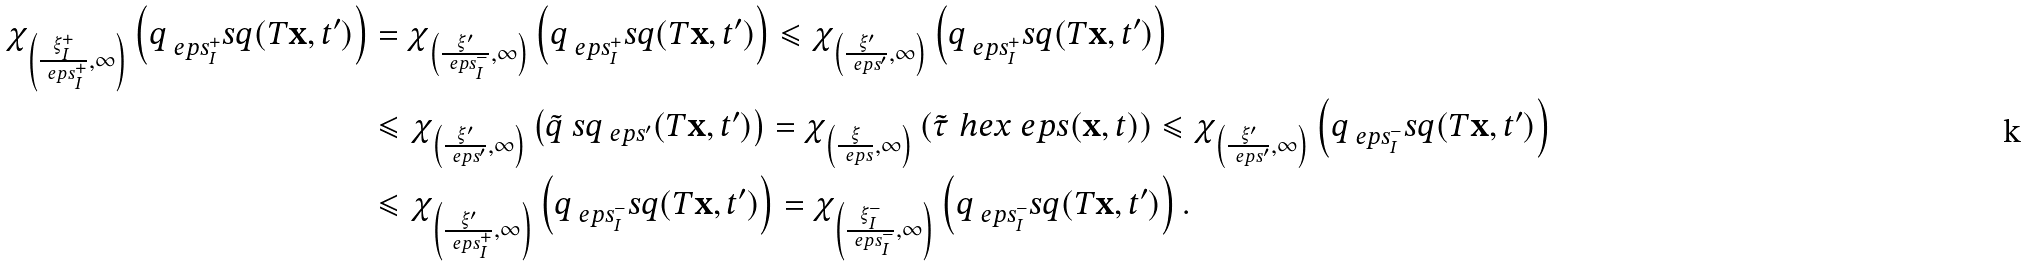Convert formula to latex. <formula><loc_0><loc_0><loc_500><loc_500>\chi _ { \left ( \frac { \xi ^ { + } _ { I } } { \ e p s ^ { + } _ { I } } , \infty \right ) } \left ( q _ { \ e p s ^ { + } _ { I } } ^ { \ } s q ( T { \mathbf x } , t ^ { \prime } ) \right ) & = \chi _ { \left ( \frac { \xi ^ { \prime } } { \ e p s ^ { - } _ { I } } , \infty \right ) } \left ( q _ { \ e p s ^ { + } _ { I } } ^ { \ } s q ( T { \mathbf x } , t ^ { \prime } ) \right ) \leqslant \chi _ { \left ( \frac { \xi ^ { \prime } } { \ e p s ^ { \prime } } , \infty \right ) } \left ( q _ { \ e p s ^ { + } _ { I } } ^ { \ } s q ( T { \mathbf x } , t ^ { \prime } ) \right ) \\ & \leqslant \chi _ { \left ( \frac { \xi ^ { \prime } } { \ e p s ^ { \prime } } , \infty \right ) } \left ( \tilde { q } ^ { \ } s q _ { \ e p s ^ { \prime } } ( T { \mathbf x } , t ^ { \prime } ) \right ) = \chi _ { \left ( \frac { \xi } { \ e p s } , \infty \right ) } \left ( \tilde { \tau } ^ { \ } h e x _ { \ } e p s ( { \mathbf x } , t ) \right ) \leqslant \chi _ { \left ( \frac { \xi ^ { \prime } } { \ e p s ^ { \prime } } , \infty \right ) } \left ( q _ { \ e p s ^ { - } _ { I } } ^ { \ } s q ( T { \mathbf x } , t ^ { \prime } ) \right ) \\ & \leqslant \chi _ { \left ( \frac { \xi ^ { \prime } } { \ e p s ^ { + } _ { I } } , \infty \right ) } \left ( q _ { \ e p s ^ { - } _ { I } } ^ { \ } s q ( T { \mathbf x } , t ^ { \prime } ) \right ) = \chi _ { \left ( \frac { \xi ^ { - } _ { I } } { \ e p s ^ { - } _ { I } } , \infty \right ) } \left ( q _ { \ e p s ^ { - } _ { I } } ^ { \ } s q ( T { \mathbf x } , t ^ { \prime } ) \right ) .</formula> 